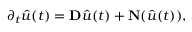Convert formula to latex. <formula><loc_0><loc_0><loc_500><loc_500>\partial _ { t } \hat { u } ( t ) = D \hat { u } ( t ) + N ( \hat { u } ( t ) ) ,</formula> 